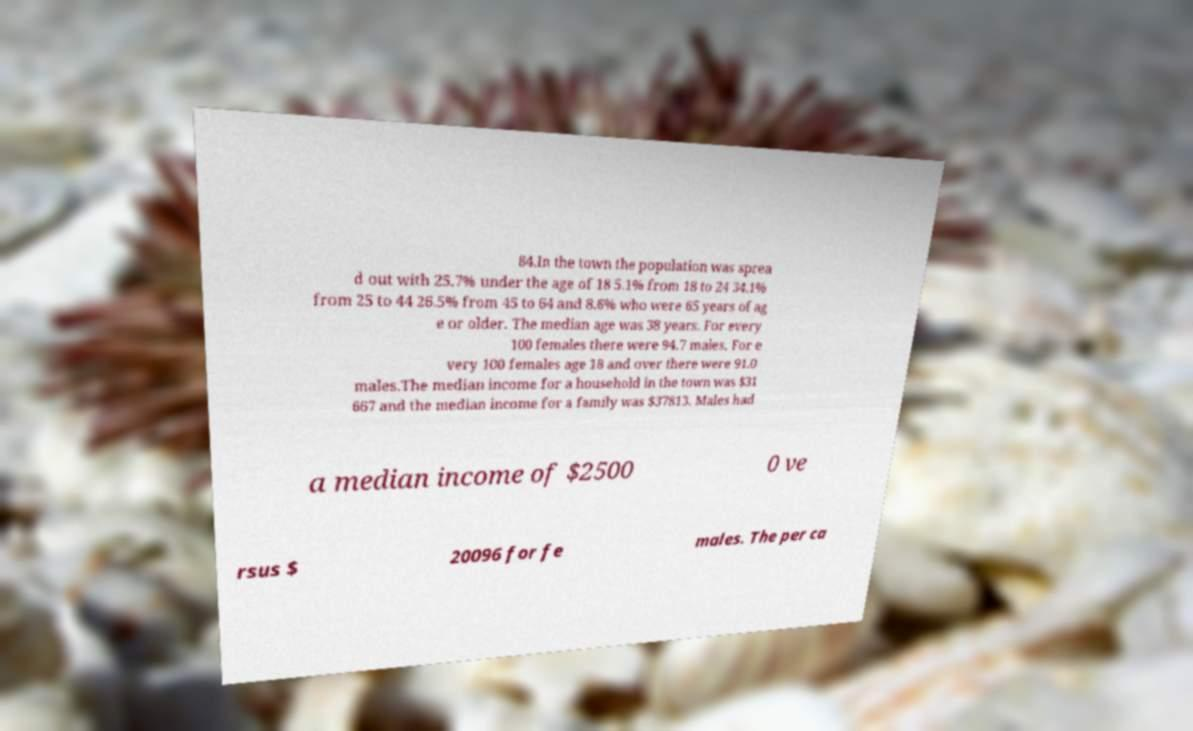Can you accurately transcribe the text from the provided image for me? 84.In the town the population was sprea d out with 25.7% under the age of 18 5.1% from 18 to 24 34.1% from 25 to 44 26.5% from 45 to 64 and 8.6% who were 65 years of ag e or older. The median age was 38 years. For every 100 females there were 94.7 males. For e very 100 females age 18 and over there were 91.0 males.The median income for a household in the town was $31 667 and the median income for a family was $37813. Males had a median income of $2500 0 ve rsus $ 20096 for fe males. The per ca 